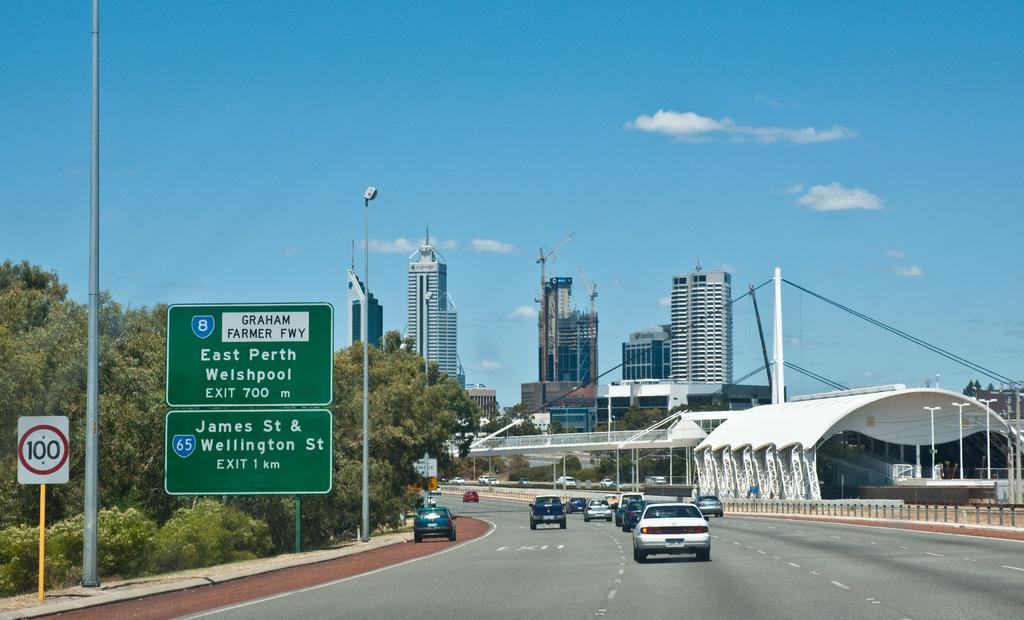What type of structures can be seen in the image? There are buildings in the image. What other natural elements are present in the image? There are trees in the image. What can be seen on the road in the image? There are vehicles on the road in the image. Can you describe a specific architectural feature in the image? There is a curved roof in the image. What are the vertical structures with wires in the image? There are electric poles in the image. What type of signs are present in the image? There are sign boards in the image. What type of barrier can be seen in the image? There is a fence in the image. What is visible in the sky in the image? There are clouds in the sky in the image. How many pizzas are being delivered by the vehicles in the image? There is no indication of pizzas or deliveries in the image; it only shows vehicles on the road. What type of whistle can be heard coming from the buildings in the image? There is no whistle or sound present in the image; it only shows visual elements. 